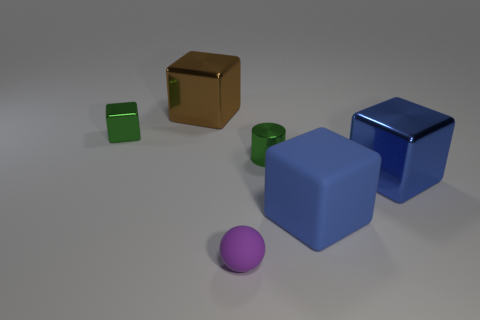Add 1 small yellow spheres. How many objects exist? 7 Subtract all large cubes. How many cubes are left? 1 Add 4 big blue matte cubes. How many big blue matte cubes exist? 5 Subtract all brown cubes. How many cubes are left? 3 Subtract 1 brown cubes. How many objects are left? 5 Subtract all cylinders. How many objects are left? 5 Subtract 1 blocks. How many blocks are left? 3 Subtract all purple blocks. Subtract all yellow cylinders. How many blocks are left? 4 Subtract all brown balls. How many brown blocks are left? 1 Subtract all small gray metal cubes. Subtract all brown metal things. How many objects are left? 5 